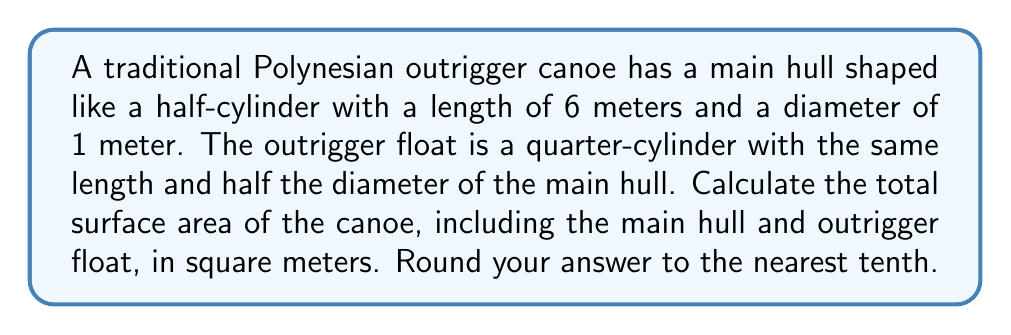Provide a solution to this math problem. Let's break this down step-by-step:

1. Calculate the surface area of the main hull:
   a) Curved surface area: $A_{curved} = \pi r l = \pi \cdot 0.5 \cdot 6 = 3\pi$ m²
   b) Flat top surface: $A_{flat} = l \cdot 2r = 6 \cdot 1 = 6$ m²
   c) Two circular ends: $A_{ends} = 2 \cdot \frac{1}{2} \pi r^2 = \pi \cdot 0.5^2 = \frac{\pi}{4}$ m²
   Total main hull surface area: $A_{main} = 3\pi + 6 + \frac{\pi}{4} = 3\frac{\pi}{4} + 6$ m²

2. Calculate the surface area of the outrigger float:
   a) Curved surface area: $A_{curved} = \frac{1}{2} \pi r l = \frac{1}{2} \pi \cdot 0.25 \cdot 6 = \frac{3\pi}{4}$ m²
   b) Flat top surface: $A_{flat} = l \cdot r = 6 \cdot 0.25 = 1.5$ m²
   c) Two quarter-circular ends: $A_{ends} = 2 \cdot \frac{1}{4} \cdot \frac{1}{2} \pi r^2 = \frac{1}{4} \pi \cdot 0.25^2 = \frac{\pi}{64}$ m²
   Total outrigger float surface area: $A_{out} = \frac{3\pi}{4} + 1.5 + \frac{\pi}{64}$ m²

3. Sum up the total surface area:
   $A_{total} = A_{main} + A_{out} = (3\frac{\pi}{4} + 6) + (\frac{3\pi}{4} + 1.5 + \frac{\pi}{64})$
   $A_{total} = 3\frac{\pi}{4} + 6 + \frac{3\pi}{4} + 1.5 + \frac{\pi}{64} = \frac{49\pi}{16} + 7.5$ m²

4. Calculate the numerical value and round to the nearest tenth:
   $A_{total} \approx 17.1$ m²
Answer: 17.1 m² 